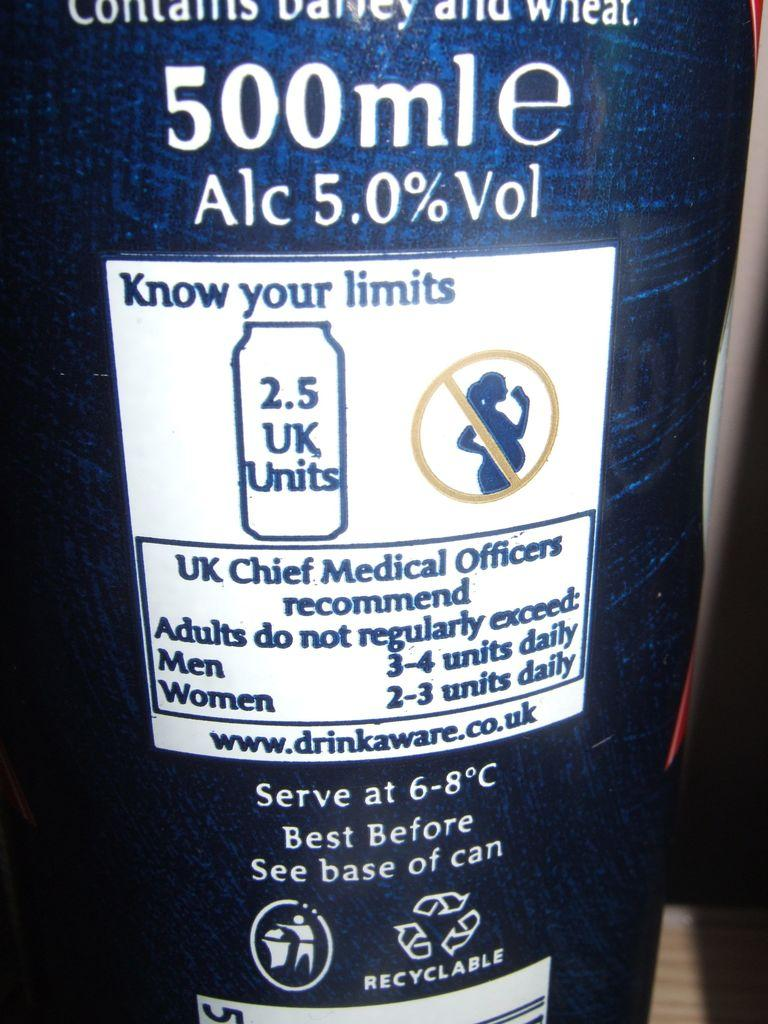<image>
Provide a brief description of the given image. Back label of beer bottle with advisory to know your limits when drinking alcohol. 